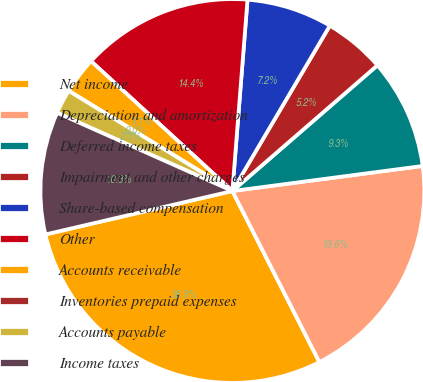Convert chart to OTSL. <chart><loc_0><loc_0><loc_500><loc_500><pie_chart><fcel>Net income<fcel>Depreciation and amortization<fcel>Deferred income taxes<fcel>Impairment and other charges<fcel>Share-based compensation<fcel>Other<fcel>Accounts receivable<fcel>Inventories prepaid expenses<fcel>Accounts payable<fcel>Income taxes<nl><fcel>28.86%<fcel>19.59%<fcel>9.28%<fcel>5.16%<fcel>7.22%<fcel>14.43%<fcel>3.09%<fcel>0.0%<fcel>2.06%<fcel>10.31%<nl></chart> 